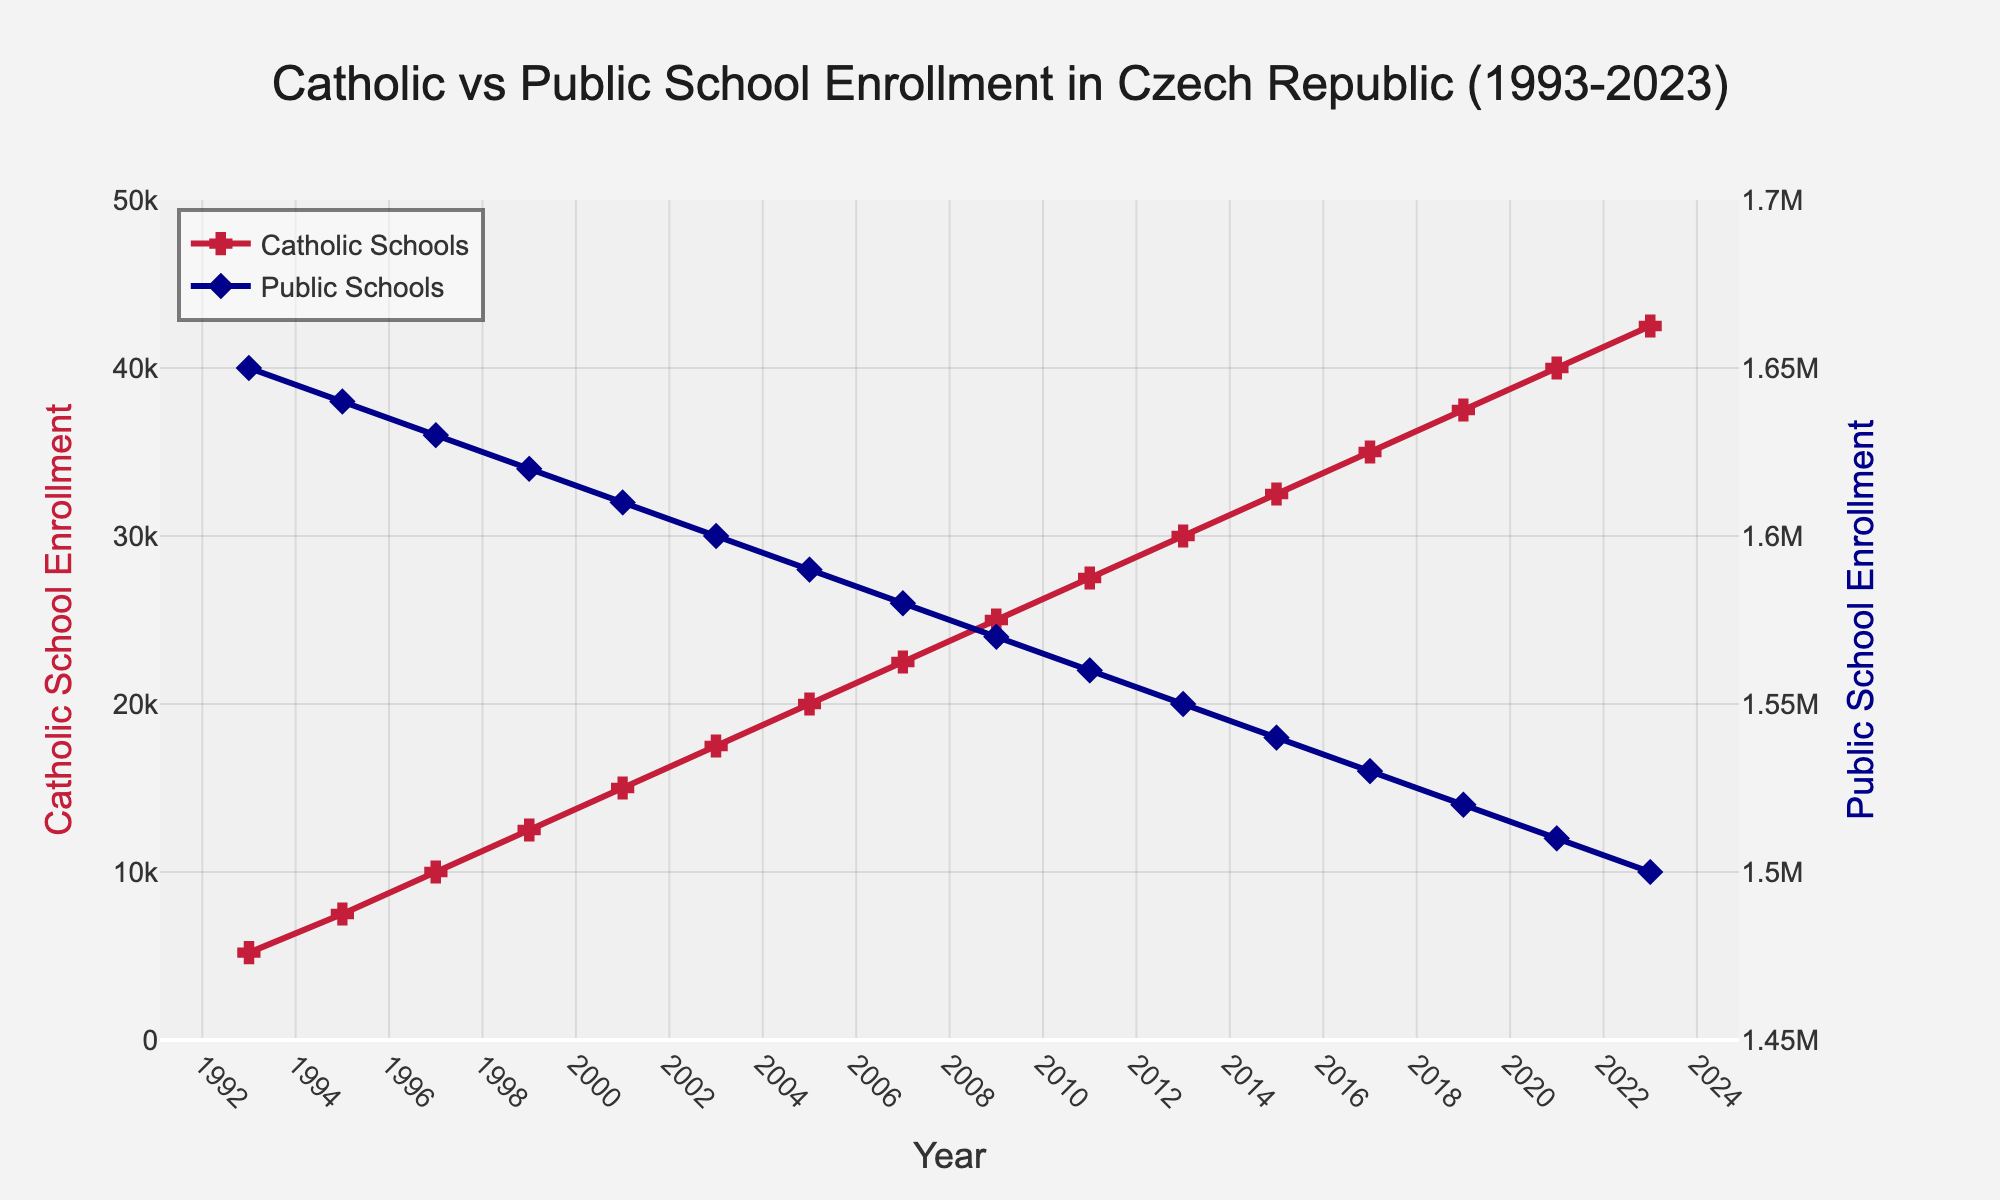What's the enrollment trend for Catholic schools over the last 30 years? Observe the line for Catholic schools; it starts at around 5,200 in 1993 and steadily rises to approximately 42,500 by 2023, indicating a consistent increase.
Answer: Increasing What year did Catholic school enrollment surpass 10,000? Look at the data points on the Catholic school enrollment line; the enrollment crosses 10,000 between 1995 and 1997.
Answer: 1997 Compare the enrollment numbers for Catholic and public schools in 2021. Check the lines at the year 2021; the Catholic school enrollment is approximately 40,000 while public school enrollment is about 1,510,000.
Answer: 40,000 vs 1,510,000 How does the trend of public school enrollment compare to that of Catholic schools? The line for public schools shows a steady decline from around 1,650,000 in 1993 to approximately 1,500,000 in 2023, while the Catholic school enrollment line shows a steady increase.
Answer: Decreasing vs Increasing In which year is the difference between Catholic and public school enrollment the greatest? Calculate the difference for each year. The maximum difference occurs at the beginning in 1993.
Answer: 1993 What is the approximate annual increase in Catholic school enrollment between 1993 and 2023? Calculate the difference between the end and start values for Catholic schools and divide by the number of years: (42500 - 5200) / (2023 - 1993) = 37300 / 30 ≈ 1243.33.
Answer: 1243 per year By how much did public school enrollment decrease between 2001 and 2011? Subtract the public school enrollment in 2011 from that in 2001: 1,610,000 - 1,560,000 = 50,000.
Answer: 50,000 What are the visual markers used for Catholic and public school enrollment lines? The figure uses crosses for Catholic school enrollment and diamonds for public school enrollment.
Answer: Crosses and diamonds Did the enrollment for Catholic schools ever decrease from one year to the next? Follow the line for Catholic school enrollment; it consistently rises every year, indicating no decrease.
Answer: No Which school type has a more pronounced trend visually? The Catholic school enrollment line increases sharply while the public school enrollment line declines moderately; the sharper trend line for Catholic schools is more pronounced.
Answer: Catholic schools 